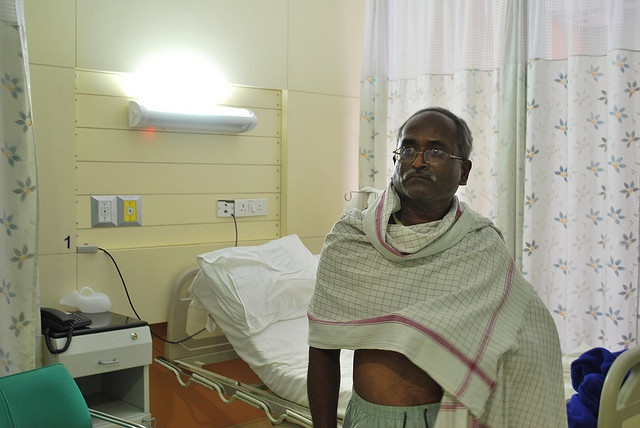Describe the objects in this image and their specific colors. I can see people in gray, darkgray, and black tones, bed in gray, darkgray, maroon, and olive tones, and chair in gray, teal, darkgreen, and black tones in this image. 